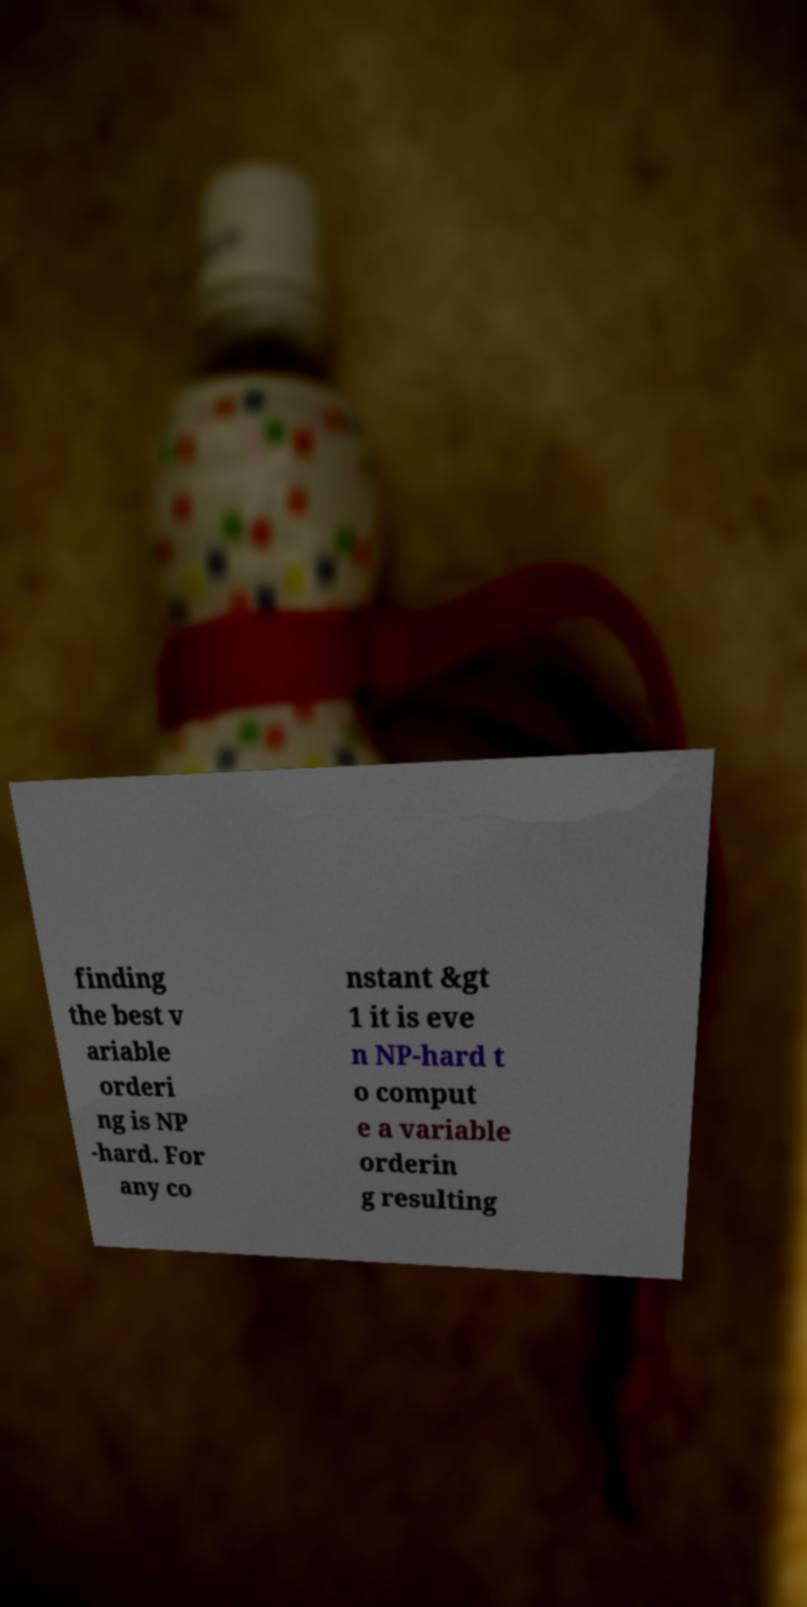Please identify and transcribe the text found in this image. finding the best v ariable orderi ng is NP -hard. For any co nstant &gt 1 it is eve n NP-hard t o comput e a variable orderin g resulting 